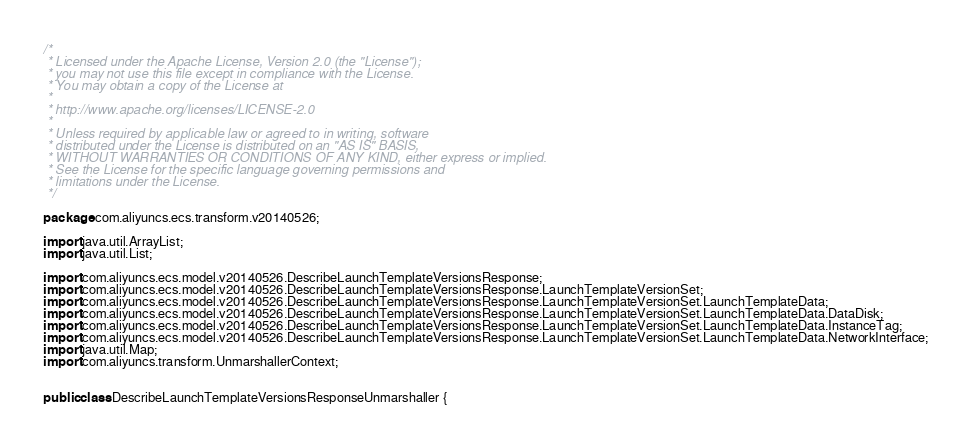Convert code to text. <code><loc_0><loc_0><loc_500><loc_500><_Java_>/*
 * Licensed under the Apache License, Version 2.0 (the "License");
 * you may not use this file except in compliance with the License.
 * You may obtain a copy of the License at
 *
 * http://www.apache.org/licenses/LICENSE-2.0
 *
 * Unless required by applicable law or agreed to in writing, software
 * distributed under the License is distributed on an "AS IS" BASIS,
 * WITHOUT WARRANTIES OR CONDITIONS OF ANY KIND, either express or implied.
 * See the License for the specific language governing permissions and
 * limitations under the License.
 */

package com.aliyuncs.ecs.transform.v20140526;

import java.util.ArrayList;
import java.util.List;

import com.aliyuncs.ecs.model.v20140526.DescribeLaunchTemplateVersionsResponse;
import com.aliyuncs.ecs.model.v20140526.DescribeLaunchTemplateVersionsResponse.LaunchTemplateVersionSet;
import com.aliyuncs.ecs.model.v20140526.DescribeLaunchTemplateVersionsResponse.LaunchTemplateVersionSet.LaunchTemplateData;
import com.aliyuncs.ecs.model.v20140526.DescribeLaunchTemplateVersionsResponse.LaunchTemplateVersionSet.LaunchTemplateData.DataDisk;
import com.aliyuncs.ecs.model.v20140526.DescribeLaunchTemplateVersionsResponse.LaunchTemplateVersionSet.LaunchTemplateData.InstanceTag;
import com.aliyuncs.ecs.model.v20140526.DescribeLaunchTemplateVersionsResponse.LaunchTemplateVersionSet.LaunchTemplateData.NetworkInterface;
import java.util.Map;
import com.aliyuncs.transform.UnmarshallerContext;


public class DescribeLaunchTemplateVersionsResponseUnmarshaller {
</code> 